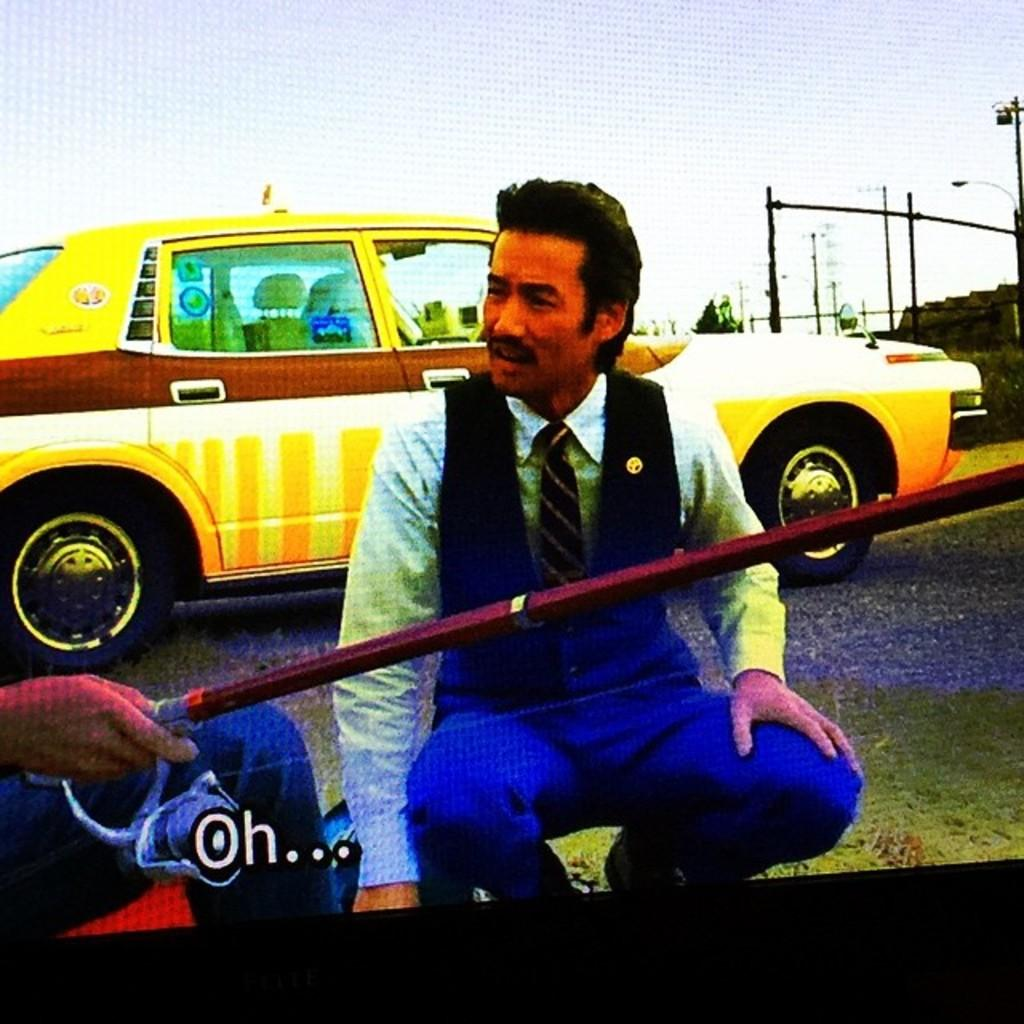<image>
Give a short and clear explanation of the subsequent image. A man dressed in a tie is squatting down by the side of a car with the text Oh... 